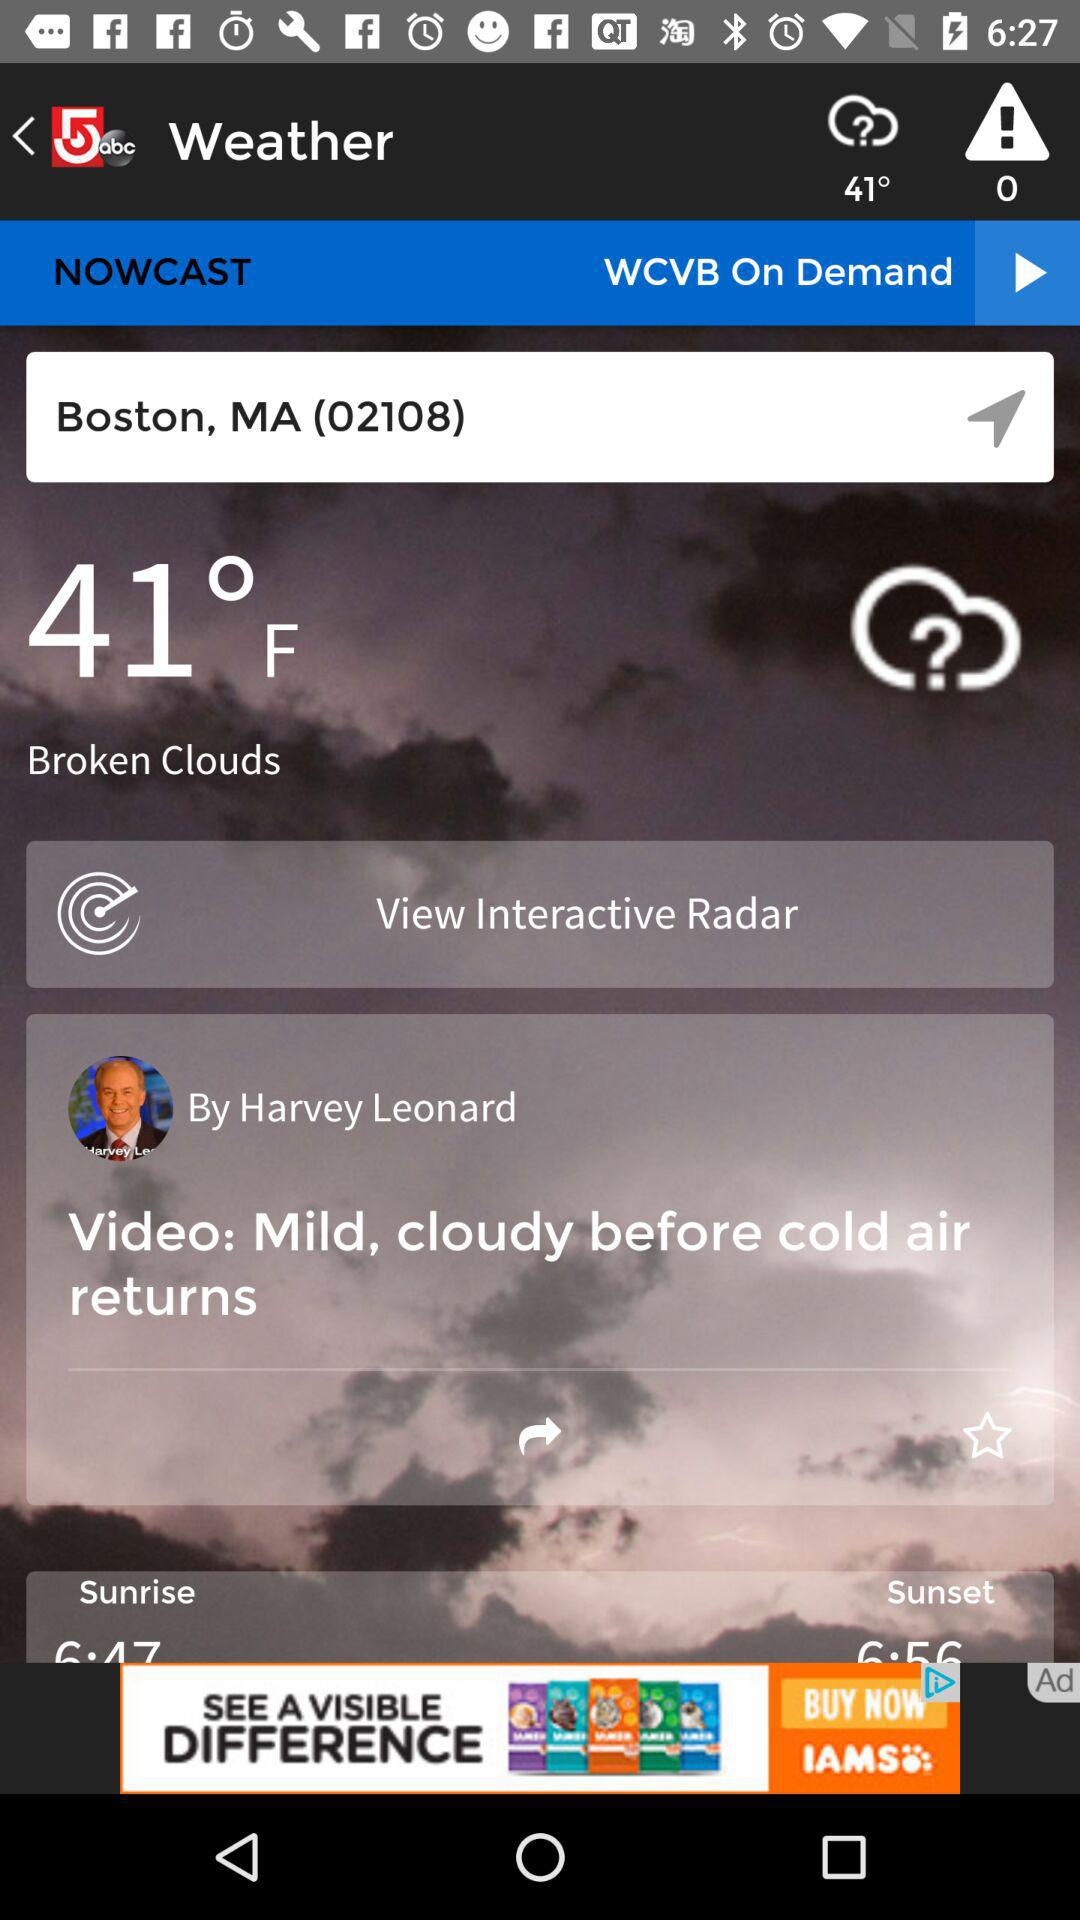What is the temperature?
Answer the question using a single word or phrase. The temperature is 41°F, 